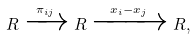Convert formula to latex. <formula><loc_0><loc_0><loc_500><loc_500>R \xrightarrow { \pi _ { i j } } R \xrightarrow { x _ { i } - x _ { j } } R ,</formula> 